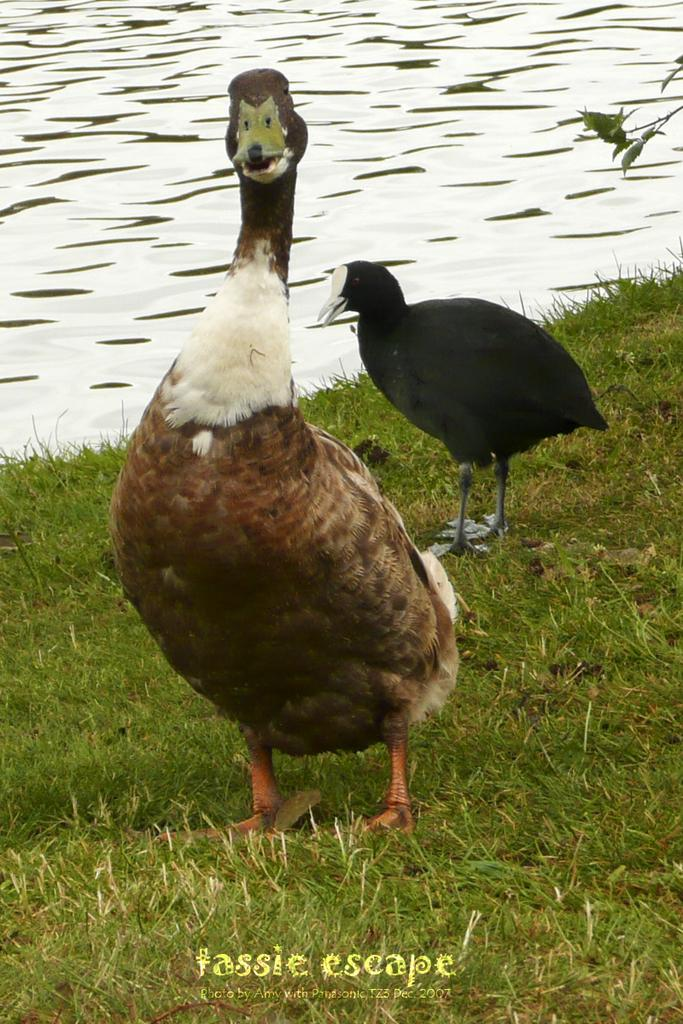What is the primary element in the image? There is water in the image. What type of animals can be seen in the image? Birds can be seen in the image. What other natural elements are present in the image? There are leaves and green grass at the bottom portion of the image. Is there any text or writing in the image? Yes, there is something written in the image. Where is the girl brushing her hair in the image? There is no girl brushing her hair in the image; it features water, birds, leaves, green grass, and written text. 